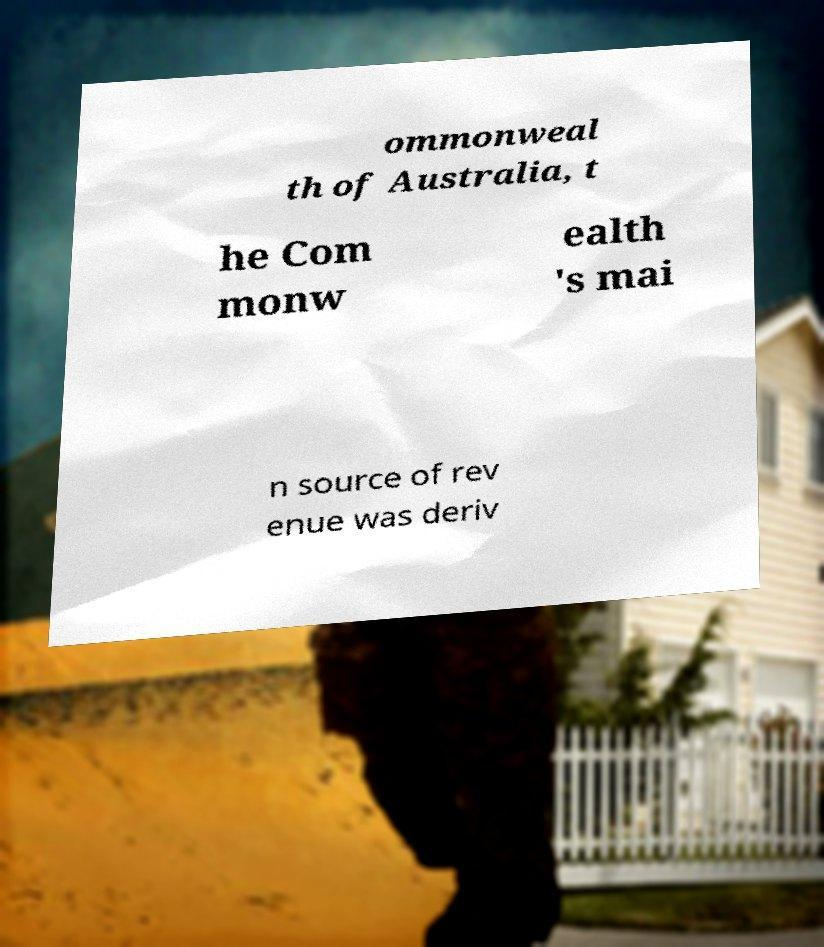Can you read and provide the text displayed in the image?This photo seems to have some interesting text. Can you extract and type it out for me? ommonweal th of Australia, t he Com monw ealth 's mai n source of rev enue was deriv 